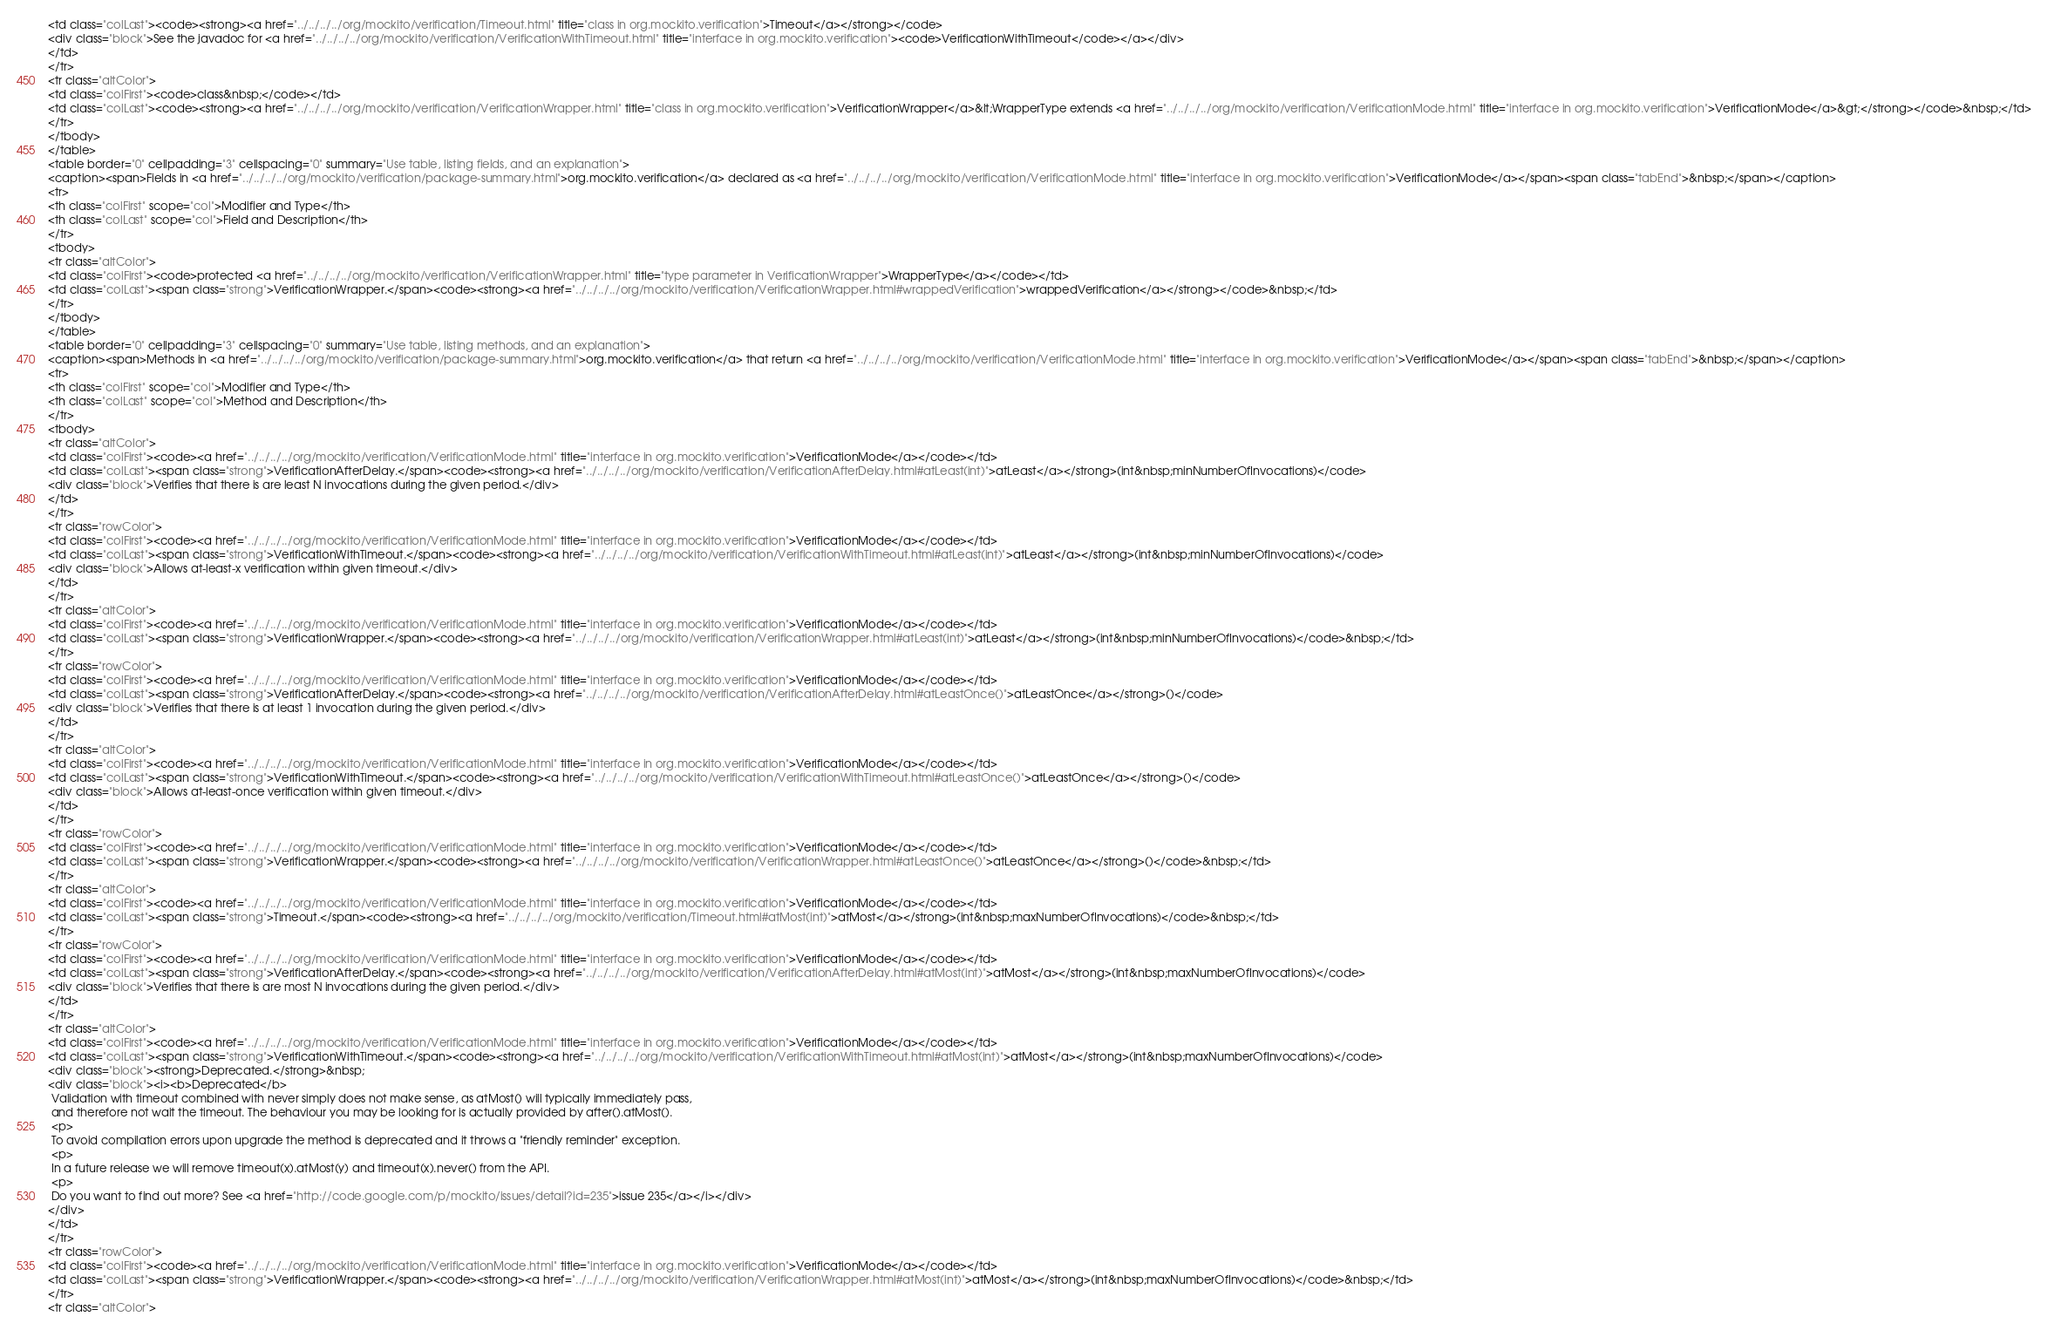<code> <loc_0><loc_0><loc_500><loc_500><_HTML_><td class="colLast"><code><strong><a href="../../../../org/mockito/verification/Timeout.html" title="class in org.mockito.verification">Timeout</a></strong></code>
<div class="block">See the javadoc for <a href="../../../../org/mockito/verification/VerificationWithTimeout.html" title="interface in org.mockito.verification"><code>VerificationWithTimeout</code></a></div>
</td>
</tr>
<tr class="altColor">
<td class="colFirst"><code>class&nbsp;</code></td>
<td class="colLast"><code><strong><a href="../../../../org/mockito/verification/VerificationWrapper.html" title="class in org.mockito.verification">VerificationWrapper</a>&lt;WrapperType extends <a href="../../../../org/mockito/verification/VerificationMode.html" title="interface in org.mockito.verification">VerificationMode</a>&gt;</strong></code>&nbsp;</td>
</tr>
</tbody>
</table>
<table border="0" cellpadding="3" cellspacing="0" summary="Use table, listing fields, and an explanation">
<caption><span>Fields in <a href="../../../../org/mockito/verification/package-summary.html">org.mockito.verification</a> declared as <a href="../../../../org/mockito/verification/VerificationMode.html" title="interface in org.mockito.verification">VerificationMode</a></span><span class="tabEnd">&nbsp;</span></caption>
<tr>
<th class="colFirst" scope="col">Modifier and Type</th>
<th class="colLast" scope="col">Field and Description</th>
</tr>
<tbody>
<tr class="altColor">
<td class="colFirst"><code>protected <a href="../../../../org/mockito/verification/VerificationWrapper.html" title="type parameter in VerificationWrapper">WrapperType</a></code></td>
<td class="colLast"><span class="strong">VerificationWrapper.</span><code><strong><a href="../../../../org/mockito/verification/VerificationWrapper.html#wrappedVerification">wrappedVerification</a></strong></code>&nbsp;</td>
</tr>
</tbody>
</table>
<table border="0" cellpadding="3" cellspacing="0" summary="Use table, listing methods, and an explanation">
<caption><span>Methods in <a href="../../../../org/mockito/verification/package-summary.html">org.mockito.verification</a> that return <a href="../../../../org/mockito/verification/VerificationMode.html" title="interface in org.mockito.verification">VerificationMode</a></span><span class="tabEnd">&nbsp;</span></caption>
<tr>
<th class="colFirst" scope="col">Modifier and Type</th>
<th class="colLast" scope="col">Method and Description</th>
</tr>
<tbody>
<tr class="altColor">
<td class="colFirst"><code><a href="../../../../org/mockito/verification/VerificationMode.html" title="interface in org.mockito.verification">VerificationMode</a></code></td>
<td class="colLast"><span class="strong">VerificationAfterDelay.</span><code><strong><a href="../../../../org/mockito/verification/VerificationAfterDelay.html#atLeast(int)">atLeast</a></strong>(int&nbsp;minNumberOfInvocations)</code>
<div class="block">Verifies that there is are least N invocations during the given period.</div>
</td>
</tr>
<tr class="rowColor">
<td class="colFirst"><code><a href="../../../../org/mockito/verification/VerificationMode.html" title="interface in org.mockito.verification">VerificationMode</a></code></td>
<td class="colLast"><span class="strong">VerificationWithTimeout.</span><code><strong><a href="../../../../org/mockito/verification/VerificationWithTimeout.html#atLeast(int)">atLeast</a></strong>(int&nbsp;minNumberOfInvocations)</code>
<div class="block">Allows at-least-x verification within given timeout.</div>
</td>
</tr>
<tr class="altColor">
<td class="colFirst"><code><a href="../../../../org/mockito/verification/VerificationMode.html" title="interface in org.mockito.verification">VerificationMode</a></code></td>
<td class="colLast"><span class="strong">VerificationWrapper.</span><code><strong><a href="../../../../org/mockito/verification/VerificationWrapper.html#atLeast(int)">atLeast</a></strong>(int&nbsp;minNumberOfInvocations)</code>&nbsp;</td>
</tr>
<tr class="rowColor">
<td class="colFirst"><code><a href="../../../../org/mockito/verification/VerificationMode.html" title="interface in org.mockito.verification">VerificationMode</a></code></td>
<td class="colLast"><span class="strong">VerificationAfterDelay.</span><code><strong><a href="../../../../org/mockito/verification/VerificationAfterDelay.html#atLeastOnce()">atLeastOnce</a></strong>()</code>
<div class="block">Verifies that there is at least 1 invocation during the given period.</div>
</td>
</tr>
<tr class="altColor">
<td class="colFirst"><code><a href="../../../../org/mockito/verification/VerificationMode.html" title="interface in org.mockito.verification">VerificationMode</a></code></td>
<td class="colLast"><span class="strong">VerificationWithTimeout.</span><code><strong><a href="../../../../org/mockito/verification/VerificationWithTimeout.html#atLeastOnce()">atLeastOnce</a></strong>()</code>
<div class="block">Allows at-least-once verification within given timeout.</div>
</td>
</tr>
<tr class="rowColor">
<td class="colFirst"><code><a href="../../../../org/mockito/verification/VerificationMode.html" title="interface in org.mockito.verification">VerificationMode</a></code></td>
<td class="colLast"><span class="strong">VerificationWrapper.</span><code><strong><a href="../../../../org/mockito/verification/VerificationWrapper.html#atLeastOnce()">atLeastOnce</a></strong>()</code>&nbsp;</td>
</tr>
<tr class="altColor">
<td class="colFirst"><code><a href="../../../../org/mockito/verification/VerificationMode.html" title="interface in org.mockito.verification">VerificationMode</a></code></td>
<td class="colLast"><span class="strong">Timeout.</span><code><strong><a href="../../../../org/mockito/verification/Timeout.html#atMost(int)">atMost</a></strong>(int&nbsp;maxNumberOfInvocations)</code>&nbsp;</td>
</tr>
<tr class="rowColor">
<td class="colFirst"><code><a href="../../../../org/mockito/verification/VerificationMode.html" title="interface in org.mockito.verification">VerificationMode</a></code></td>
<td class="colLast"><span class="strong">VerificationAfterDelay.</span><code><strong><a href="../../../../org/mockito/verification/VerificationAfterDelay.html#atMost(int)">atMost</a></strong>(int&nbsp;maxNumberOfInvocations)</code>
<div class="block">Verifies that there is are most N invocations during the given period.</div>
</td>
</tr>
<tr class="altColor">
<td class="colFirst"><code><a href="../../../../org/mockito/verification/VerificationMode.html" title="interface in org.mockito.verification">VerificationMode</a></code></td>
<td class="colLast"><span class="strong">VerificationWithTimeout.</span><code><strong><a href="../../../../org/mockito/verification/VerificationWithTimeout.html#atMost(int)">atMost</a></strong>(int&nbsp;maxNumberOfInvocations)</code>
<div class="block"><strong>Deprecated.</strong>&nbsp;
<div class="block"><i><b>Deprecated</b>
 Validation with timeout combined with never simply does not make sense, as atMost() will typically immediately pass,
 and therefore not wait the timeout. The behaviour you may be looking for is actually provided by after().atMost(). 
 <p>
 To avoid compilation errors upon upgrade the method is deprecated and it throws a "friendly reminder" exception.
 <p>
 In a future release we will remove timeout(x).atMost(y) and timeout(x).never() from the API.
 <p>
 Do you want to find out more? See <a href="http://code.google.com/p/mockito/issues/detail?id=235">issue 235</a></i></div>
</div>
</td>
</tr>
<tr class="rowColor">
<td class="colFirst"><code><a href="../../../../org/mockito/verification/VerificationMode.html" title="interface in org.mockito.verification">VerificationMode</a></code></td>
<td class="colLast"><span class="strong">VerificationWrapper.</span><code><strong><a href="../../../../org/mockito/verification/VerificationWrapper.html#atMost(int)">atMost</a></strong>(int&nbsp;maxNumberOfInvocations)</code>&nbsp;</td>
</tr>
<tr class="altColor"></code> 